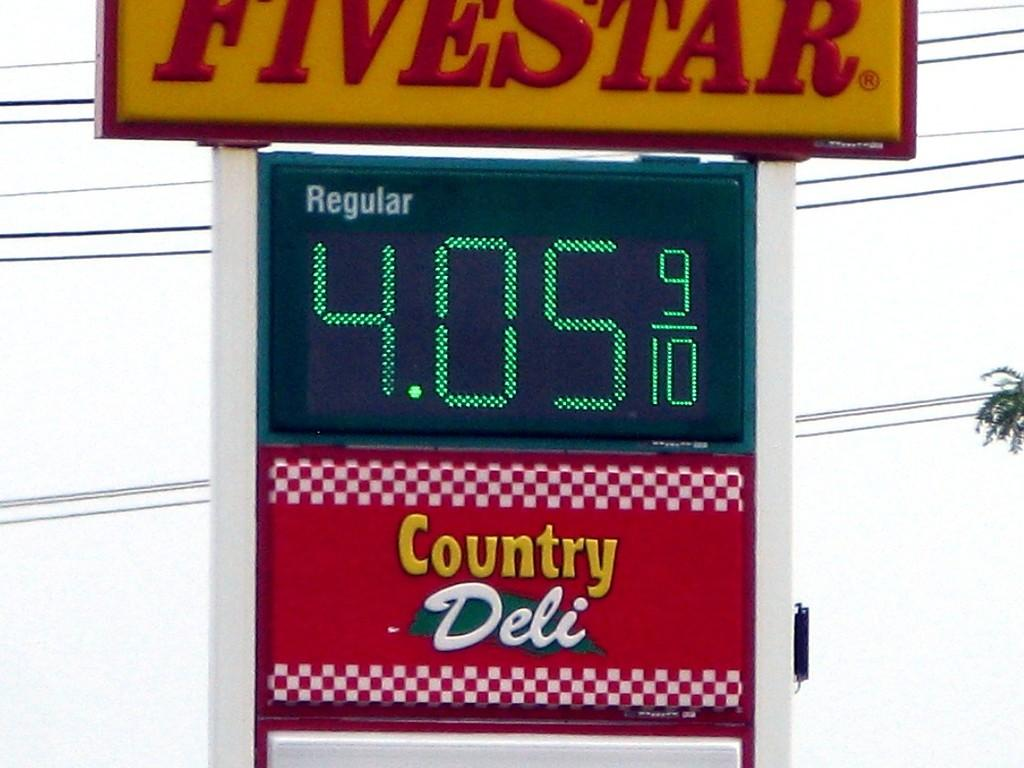Provide a one-sentence caption for the provided image. The Fivestar gas station is selling regular gas for 4.05. 